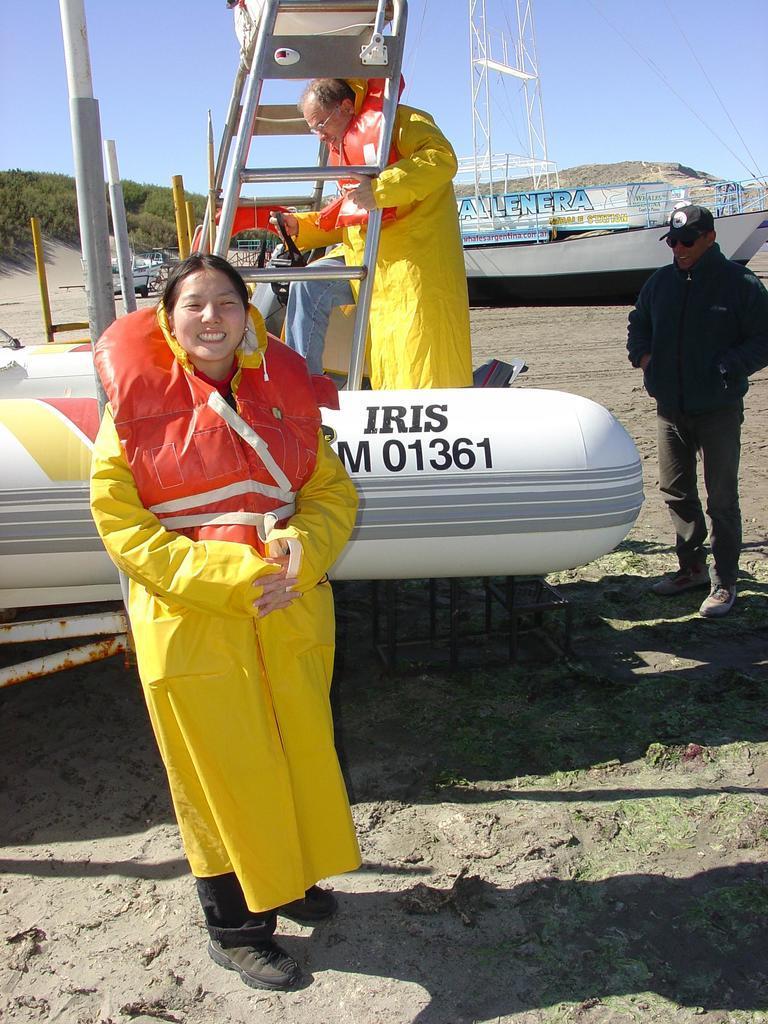Please provide a concise description of this image. In this image I can see three people were two of them wearing same color of dress. I can see one is a woman and two are men. Here I can see two boats and in the background I can see sky and trees. Here woman is smiling. 